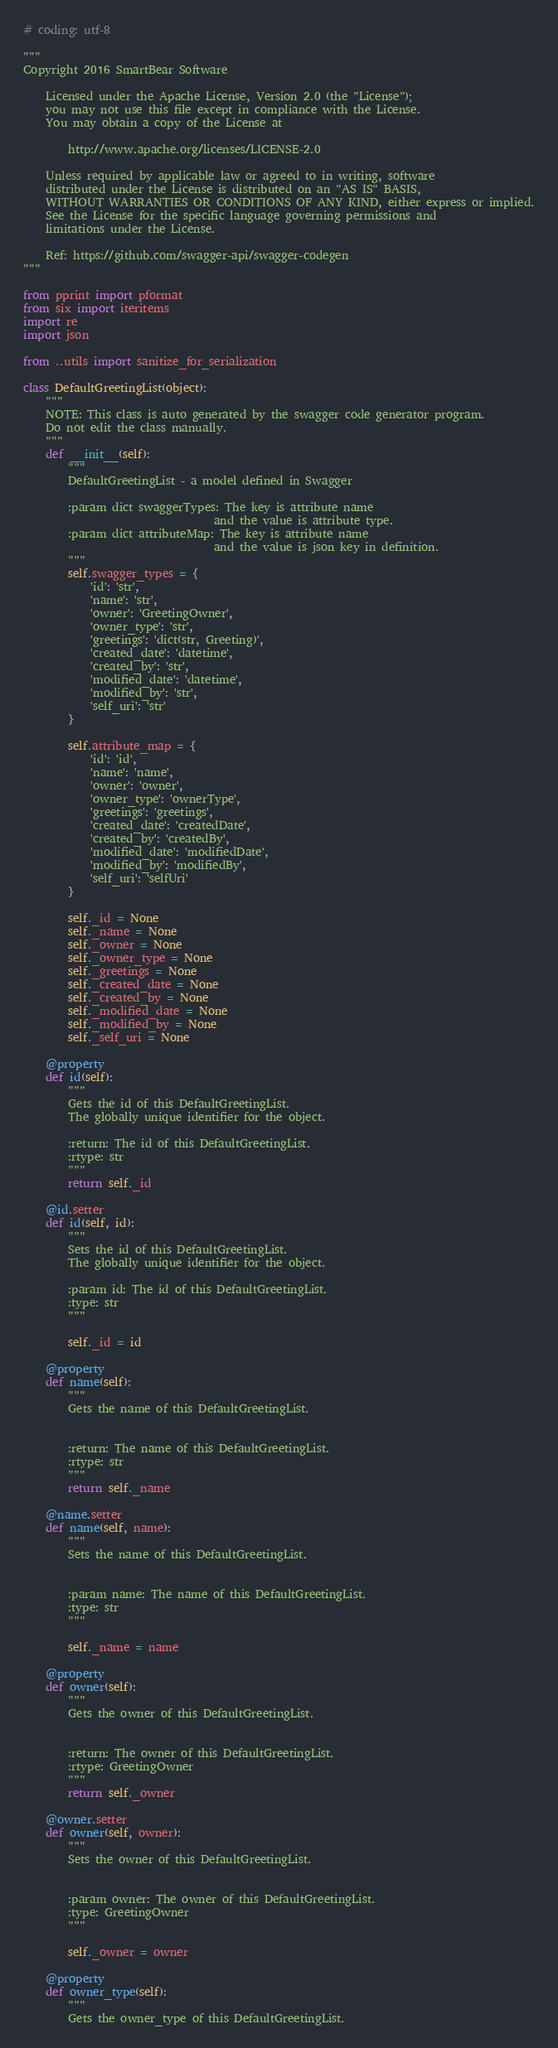<code> <loc_0><loc_0><loc_500><loc_500><_Python_># coding: utf-8

"""
Copyright 2016 SmartBear Software

    Licensed under the Apache License, Version 2.0 (the "License");
    you may not use this file except in compliance with the License.
    You may obtain a copy of the License at

        http://www.apache.org/licenses/LICENSE-2.0

    Unless required by applicable law or agreed to in writing, software
    distributed under the License is distributed on an "AS IS" BASIS,
    WITHOUT WARRANTIES OR CONDITIONS OF ANY KIND, either express or implied.
    See the License for the specific language governing permissions and
    limitations under the License.

    Ref: https://github.com/swagger-api/swagger-codegen
"""

from pprint import pformat
from six import iteritems
import re
import json

from ..utils import sanitize_for_serialization

class DefaultGreetingList(object):
    """
    NOTE: This class is auto generated by the swagger code generator program.
    Do not edit the class manually.
    """
    def __init__(self):
        """
        DefaultGreetingList - a model defined in Swagger

        :param dict swaggerTypes: The key is attribute name
                                  and the value is attribute type.
        :param dict attributeMap: The key is attribute name
                                  and the value is json key in definition.
        """
        self.swagger_types = {
            'id': 'str',
            'name': 'str',
            'owner': 'GreetingOwner',
            'owner_type': 'str',
            'greetings': 'dict(str, Greeting)',
            'created_date': 'datetime',
            'created_by': 'str',
            'modified_date': 'datetime',
            'modified_by': 'str',
            'self_uri': 'str'
        }

        self.attribute_map = {
            'id': 'id',
            'name': 'name',
            'owner': 'owner',
            'owner_type': 'ownerType',
            'greetings': 'greetings',
            'created_date': 'createdDate',
            'created_by': 'createdBy',
            'modified_date': 'modifiedDate',
            'modified_by': 'modifiedBy',
            'self_uri': 'selfUri'
        }

        self._id = None
        self._name = None
        self._owner = None
        self._owner_type = None
        self._greetings = None
        self._created_date = None
        self._created_by = None
        self._modified_date = None
        self._modified_by = None
        self._self_uri = None

    @property
    def id(self):
        """
        Gets the id of this DefaultGreetingList.
        The globally unique identifier for the object.

        :return: The id of this DefaultGreetingList.
        :rtype: str
        """
        return self._id

    @id.setter
    def id(self, id):
        """
        Sets the id of this DefaultGreetingList.
        The globally unique identifier for the object.

        :param id: The id of this DefaultGreetingList.
        :type: str
        """
        
        self._id = id

    @property
    def name(self):
        """
        Gets the name of this DefaultGreetingList.


        :return: The name of this DefaultGreetingList.
        :rtype: str
        """
        return self._name

    @name.setter
    def name(self, name):
        """
        Sets the name of this DefaultGreetingList.


        :param name: The name of this DefaultGreetingList.
        :type: str
        """
        
        self._name = name

    @property
    def owner(self):
        """
        Gets the owner of this DefaultGreetingList.


        :return: The owner of this DefaultGreetingList.
        :rtype: GreetingOwner
        """
        return self._owner

    @owner.setter
    def owner(self, owner):
        """
        Sets the owner of this DefaultGreetingList.


        :param owner: The owner of this DefaultGreetingList.
        :type: GreetingOwner
        """
        
        self._owner = owner

    @property
    def owner_type(self):
        """
        Gets the owner_type of this DefaultGreetingList.

</code> 